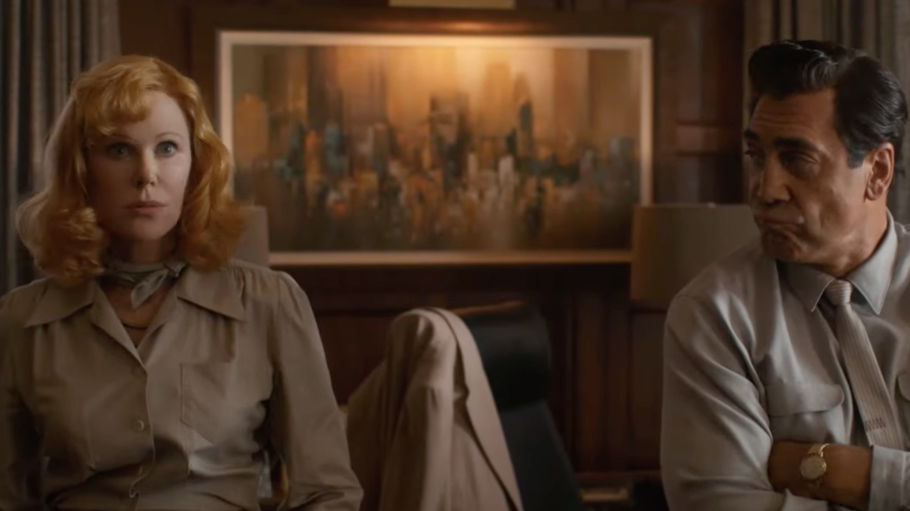Can you describe the emotions reflected in the characters' expressions and how they might relate to the story? The man appears reflective or perhaps concerned, indicative of a moment of decision or conflict related to the plot, possibly involving ethical dilemmas or personal challenges. The woman’s direct gaze and neutral expression might suggest she is a key player in the narrative, possibly holding significant information or awaiting a response. Their expressions open up a narrative filled with tension and potential confrontation. 